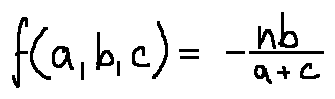<formula> <loc_0><loc_0><loc_500><loc_500>f ( a , b , c ) = - \frac { n b } { a + c }</formula> 